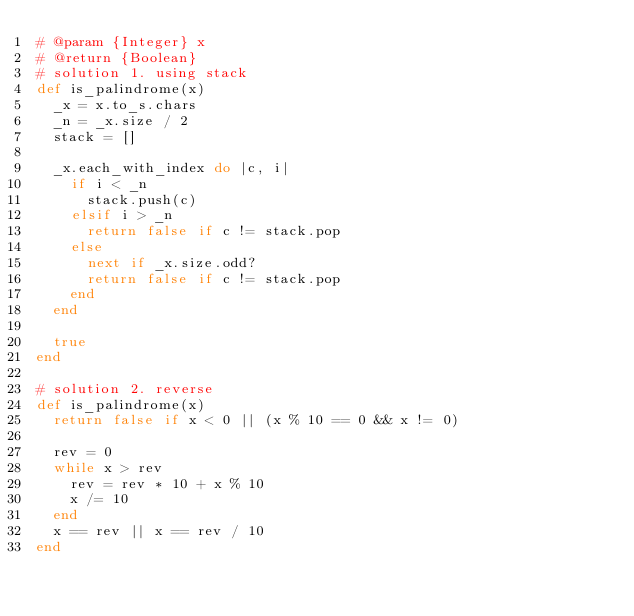<code> <loc_0><loc_0><loc_500><loc_500><_Ruby_># @param {Integer} x
# @return {Boolean}
# solution 1. using stack
def is_palindrome(x)
  _x = x.to_s.chars
  _n = _x.size / 2
  stack = []
  
  _x.each_with_index do |c, i|
    if i < _n
      stack.push(c) 
    elsif i > _n
      return false if c != stack.pop
    else
      next if _x.size.odd?
      return false if c != stack.pop
    end
  end

  true
end

# solution 2. reverse
def is_palindrome(x)
  return false if x < 0 || (x % 10 == 0 && x != 0)

  rev = 0
  while x > rev
    rev = rev * 10 + x % 10
    x /= 10
  end
  x == rev || x == rev / 10
end

</code> 